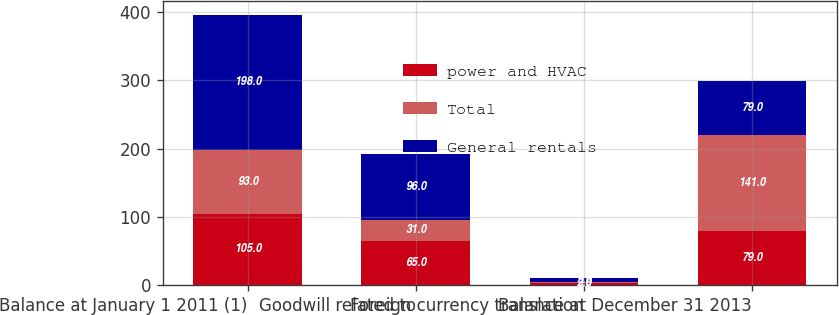Convert chart. <chart><loc_0><loc_0><loc_500><loc_500><stacked_bar_chart><ecel><fcel>Balance at January 1 2011 (1)<fcel>Goodwill related to<fcel>Foreign currency translation<fcel>Balance at December 31 2013<nl><fcel>power and HVAC<fcel>105<fcel>65<fcel>3<fcel>79<nl><fcel>Total<fcel>93<fcel>31<fcel>2<fcel>141<nl><fcel>General rentals<fcel>198<fcel>96<fcel>5<fcel>79<nl></chart> 